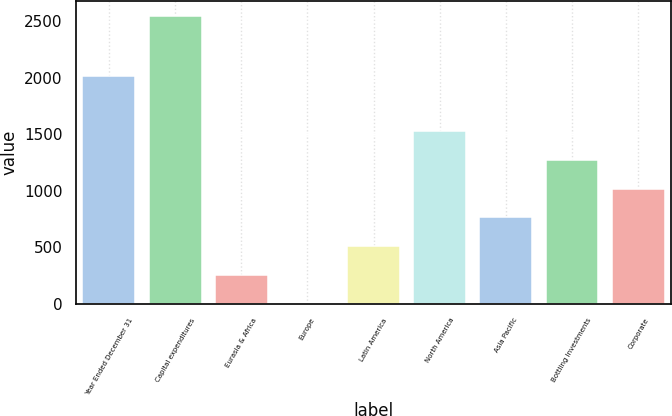Convert chart. <chart><loc_0><loc_0><loc_500><loc_500><bar_chart><fcel>Year Ended December 31<fcel>Capital expenditures<fcel>Eurasia & Africa<fcel>Europe<fcel>Latin America<fcel>North America<fcel>Asia Pacific<fcel>Bottling Investments<fcel>Corporate<nl><fcel>2013<fcel>2550<fcel>256.17<fcel>1.3<fcel>511.04<fcel>1530.52<fcel>765.91<fcel>1275.65<fcel>1020.78<nl></chart> 